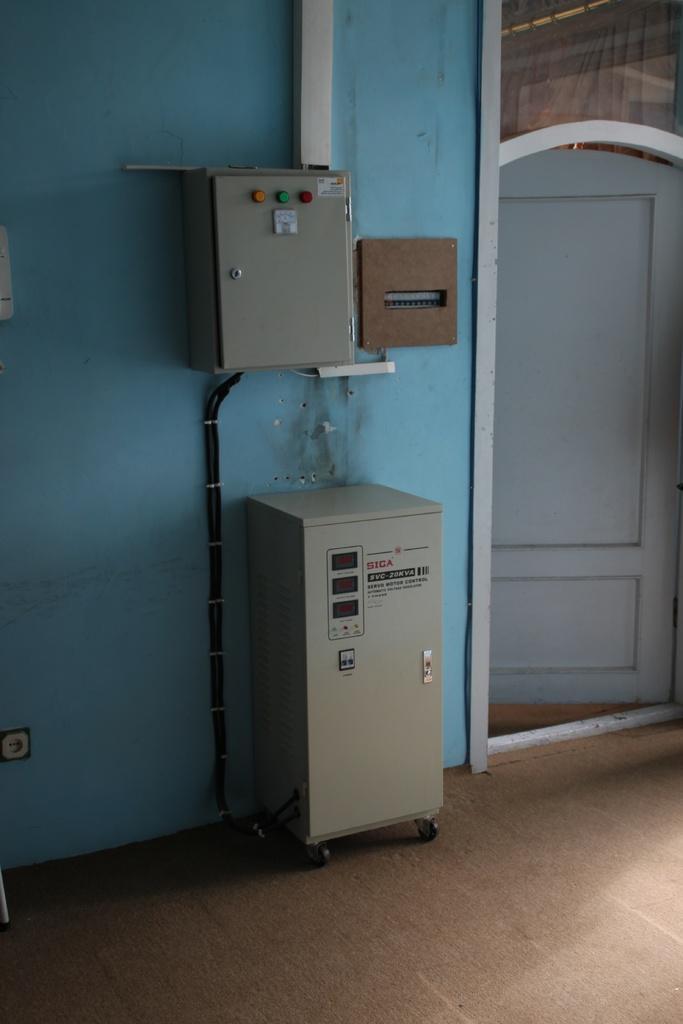Please provide a concise description of this image. In this image there are control panel boards, wall, door. 